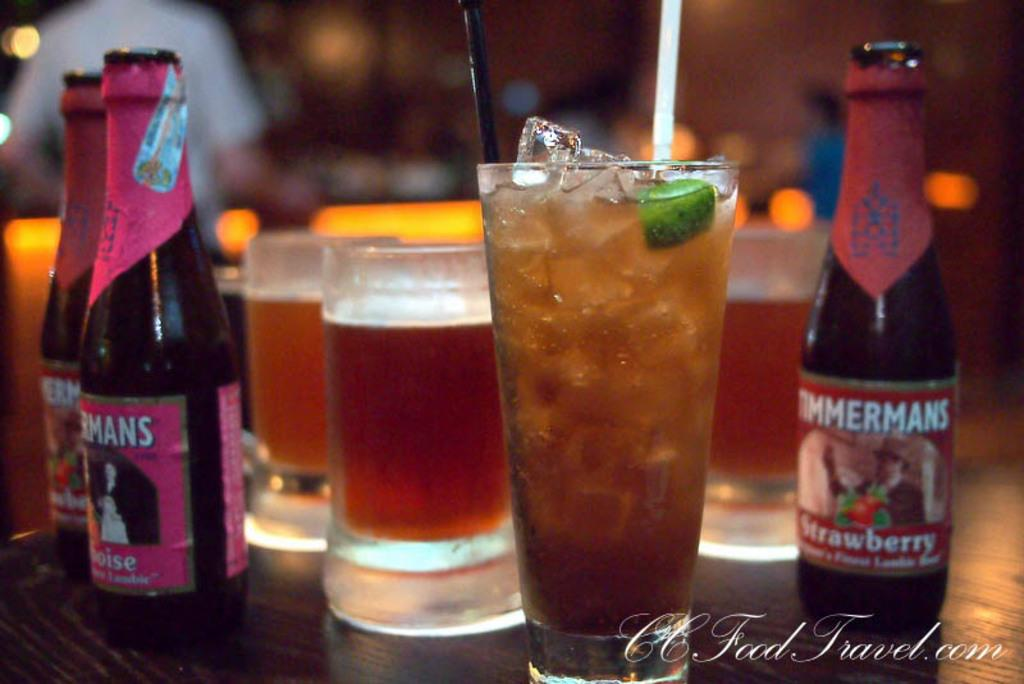What objects are present in the image that can hold liquids? There are bottles and glasses in the image that can hold liquids. What is inside the glasses in the image? The glasses contain a drink. What type of gold jewelry can be seen on the glasses in the image? There is no gold jewelry present on the glasses in the image. What type of shade is covering the glasses in the image? There is no shade covering the glasses in the image; they are visible and not obstructed. 